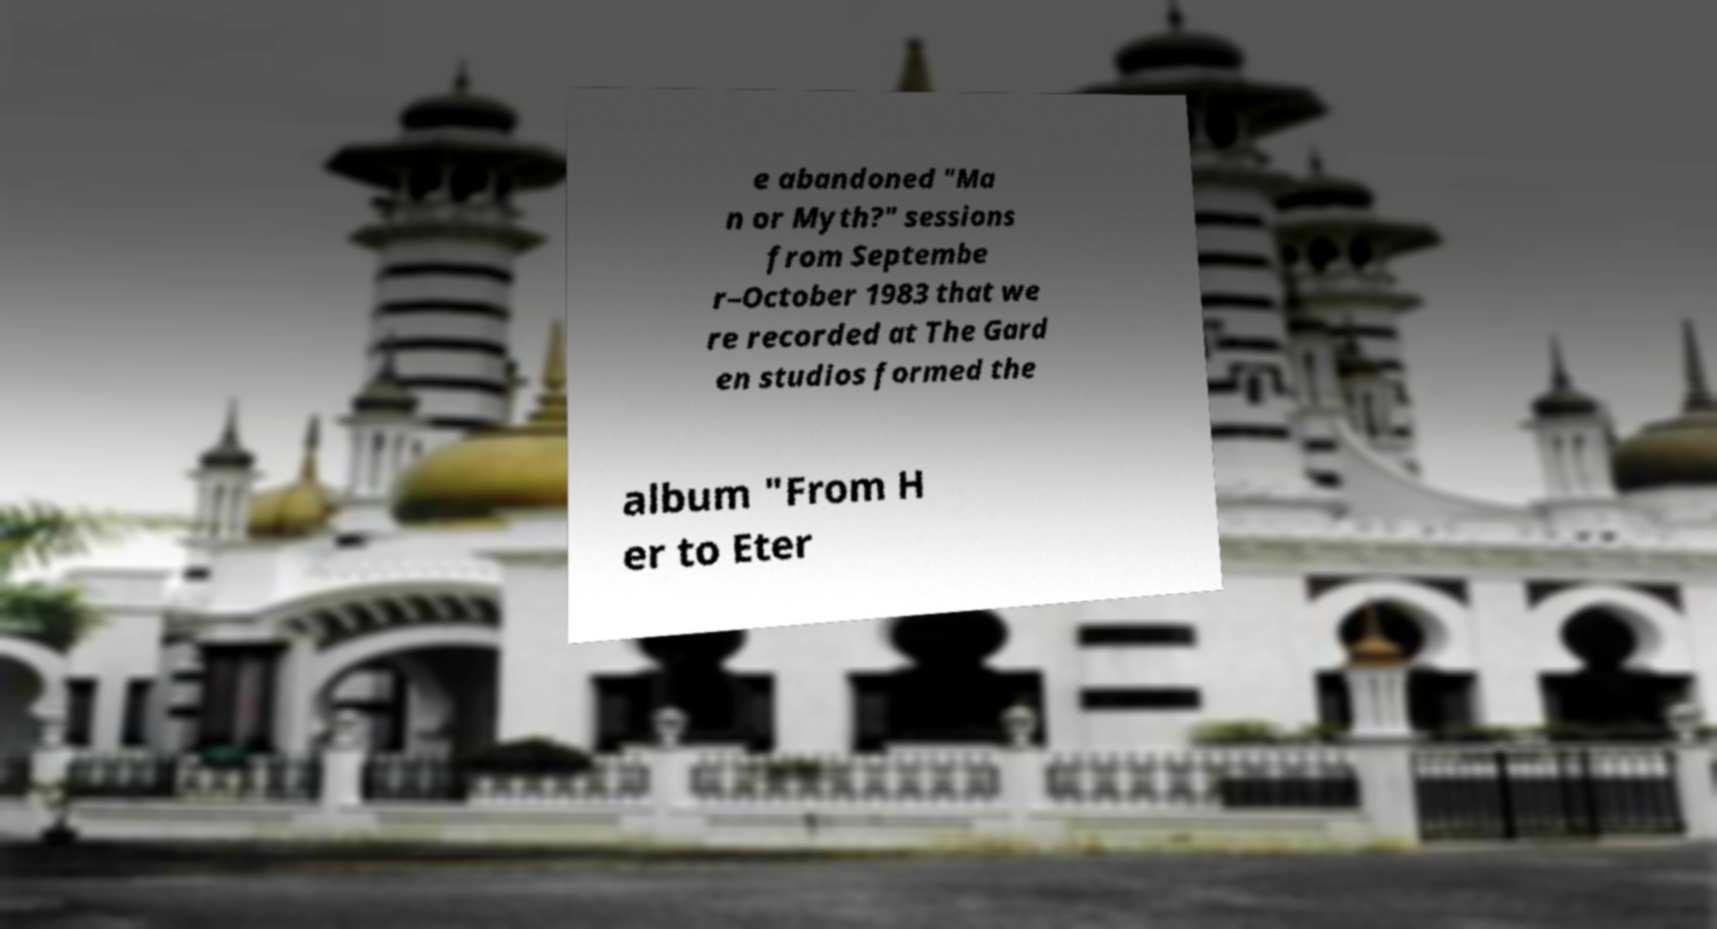Could you extract and type out the text from this image? e abandoned "Ma n or Myth?" sessions from Septembe r–October 1983 that we re recorded at The Gard en studios formed the album "From H er to Eter 